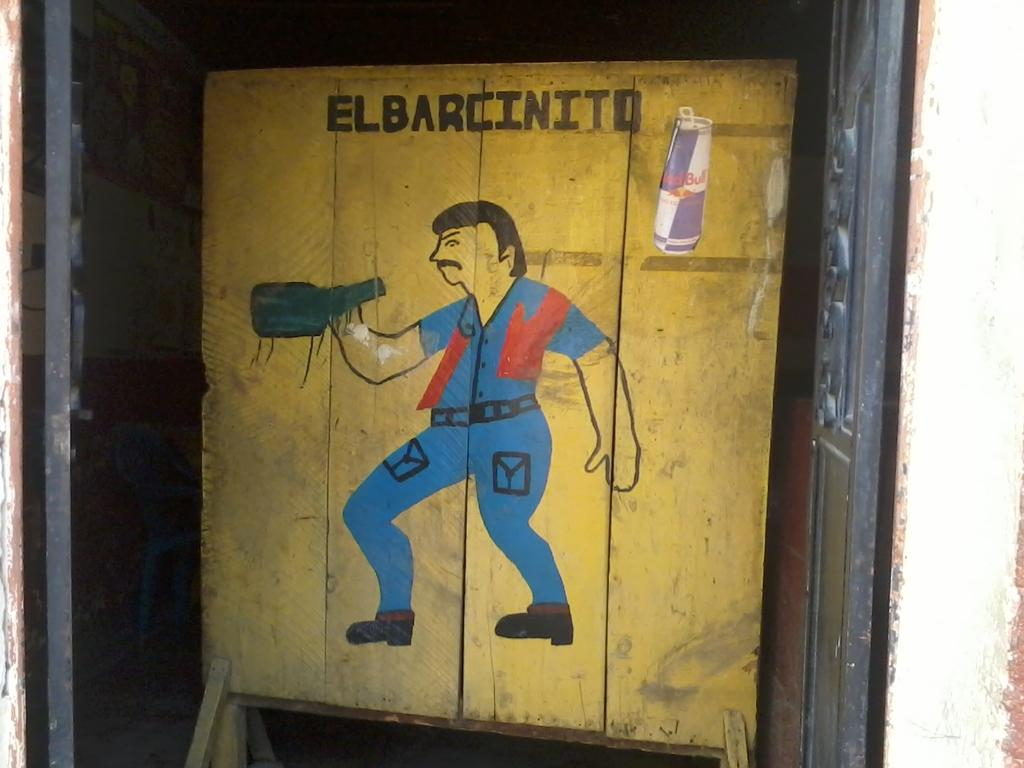Provide a one-sentence caption for the provided image. A cartoon depiction of man drinking from a blue bottle with a Red Bull can in the upper right corner. 